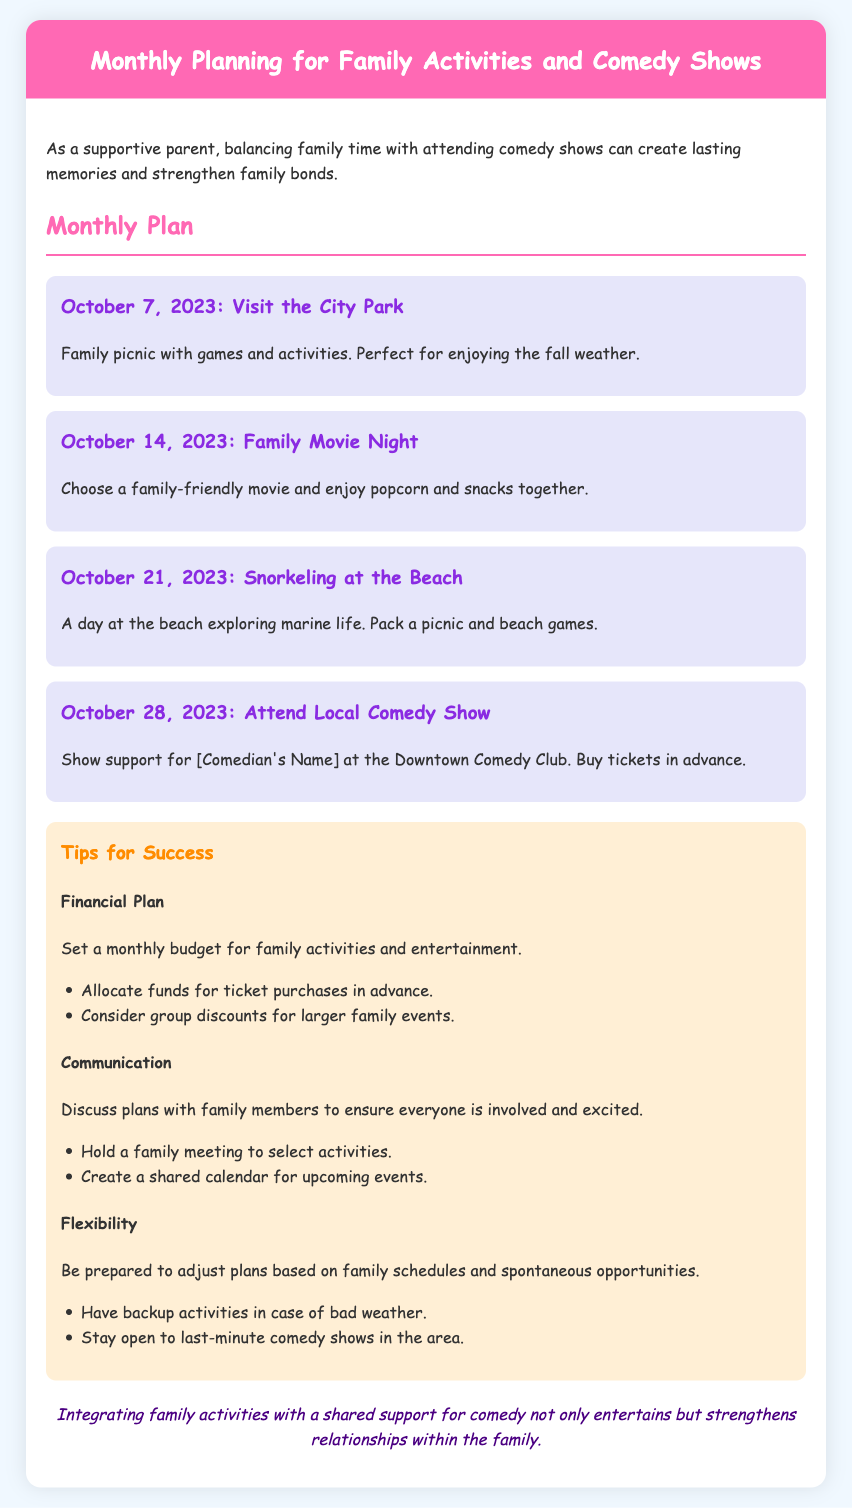What is the first family activity planned for October? The first family activity planned for October is visiting the City Park.
Answer: Visit the City Park What date is the local comedy show scheduled for? The local comedy show is scheduled for October 28, 2023.
Answer: October 28, 2023 What should families bring for the snorkeling activity? For the snorkeling activity, families should pack a picnic and beach games.
Answer: Picnic and beach games What is a suggested method for communication within the family? A suggested method for communication within the family is holding a family meeting to select activities.
Answer: Family meeting What is the main purpose of the memo? The main purpose of the memo is to plan monthly family activities and attend comedy shows together.
Answer: To plan monthly activities and attend comedy shows How should the family budget for the activities? The family should set a monthly budget for family activities and entertainment.
Answer: Monthly budget What color is used for the header background? The color used for the header background is pink.
Answer: Pink What is suggested for flexibility in planning? It is suggested to have backup activities in case of bad weather.
Answer: Backup activities 